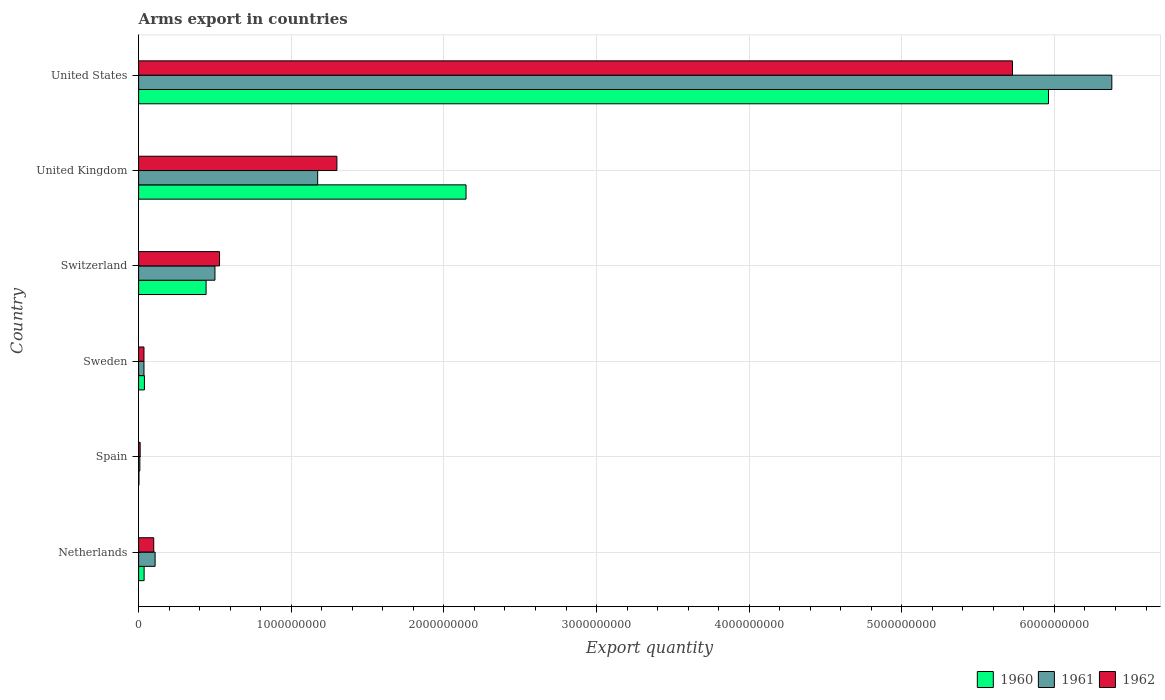How many different coloured bars are there?
Your answer should be compact. 3. Are the number of bars per tick equal to the number of legend labels?
Provide a succinct answer. Yes. Are the number of bars on each tick of the Y-axis equal?
Provide a succinct answer. Yes. What is the label of the 3rd group of bars from the top?
Provide a succinct answer. Switzerland. In how many cases, is the number of bars for a given country not equal to the number of legend labels?
Your response must be concise. 0. Across all countries, what is the maximum total arms export in 1962?
Ensure brevity in your answer.  5.72e+09. In which country was the total arms export in 1960 minimum?
Your answer should be compact. Spain. What is the total total arms export in 1961 in the graph?
Your response must be concise. 8.20e+09. What is the difference between the total arms export in 1960 in Switzerland and that in United States?
Give a very brief answer. -5.52e+09. What is the difference between the total arms export in 1960 in United Kingdom and the total arms export in 1961 in United States?
Your answer should be very brief. -4.23e+09. What is the average total arms export in 1960 per country?
Provide a short and direct response. 1.44e+09. What is the difference between the total arms export in 1960 and total arms export in 1961 in United Kingdom?
Your answer should be compact. 9.72e+08. In how many countries, is the total arms export in 1962 greater than 5400000000 ?
Give a very brief answer. 1. What is the ratio of the total arms export in 1960 in Netherlands to that in Sweden?
Ensure brevity in your answer.  0.95. Is the difference between the total arms export in 1960 in Spain and Switzerland greater than the difference between the total arms export in 1961 in Spain and Switzerland?
Make the answer very short. Yes. What is the difference between the highest and the second highest total arms export in 1962?
Give a very brief answer. 4.43e+09. What is the difference between the highest and the lowest total arms export in 1961?
Offer a very short reply. 6.37e+09. Is it the case that in every country, the sum of the total arms export in 1960 and total arms export in 1962 is greater than the total arms export in 1961?
Your response must be concise. Yes. How many bars are there?
Offer a terse response. 18. Are the values on the major ticks of X-axis written in scientific E-notation?
Make the answer very short. No. Does the graph contain grids?
Your answer should be very brief. Yes. Where does the legend appear in the graph?
Keep it short and to the point. Bottom right. How many legend labels are there?
Your answer should be very brief. 3. What is the title of the graph?
Offer a very short reply. Arms export in countries. Does "1990" appear as one of the legend labels in the graph?
Your answer should be compact. No. What is the label or title of the X-axis?
Offer a terse response. Export quantity. What is the Export quantity of 1960 in Netherlands?
Provide a short and direct response. 3.60e+07. What is the Export quantity in 1961 in Netherlands?
Your answer should be very brief. 1.08e+08. What is the Export quantity in 1962 in Netherlands?
Offer a very short reply. 9.90e+07. What is the Export quantity of 1962 in Spain?
Your answer should be very brief. 1.00e+07. What is the Export quantity of 1960 in Sweden?
Give a very brief answer. 3.80e+07. What is the Export quantity of 1961 in Sweden?
Ensure brevity in your answer.  3.50e+07. What is the Export quantity of 1962 in Sweden?
Your answer should be very brief. 3.50e+07. What is the Export quantity in 1960 in Switzerland?
Ensure brevity in your answer.  4.42e+08. What is the Export quantity in 1961 in Switzerland?
Your response must be concise. 5.00e+08. What is the Export quantity in 1962 in Switzerland?
Make the answer very short. 5.30e+08. What is the Export quantity in 1960 in United Kingdom?
Provide a succinct answer. 2.14e+09. What is the Export quantity of 1961 in United Kingdom?
Provide a succinct answer. 1.17e+09. What is the Export quantity of 1962 in United Kingdom?
Keep it short and to the point. 1.30e+09. What is the Export quantity of 1960 in United States?
Provide a succinct answer. 5.96e+09. What is the Export quantity of 1961 in United States?
Provide a succinct answer. 6.38e+09. What is the Export quantity of 1962 in United States?
Your answer should be very brief. 5.72e+09. Across all countries, what is the maximum Export quantity of 1960?
Give a very brief answer. 5.96e+09. Across all countries, what is the maximum Export quantity of 1961?
Your answer should be compact. 6.38e+09. Across all countries, what is the maximum Export quantity in 1962?
Keep it short and to the point. 5.72e+09. Across all countries, what is the minimum Export quantity of 1962?
Ensure brevity in your answer.  1.00e+07. What is the total Export quantity of 1960 in the graph?
Your response must be concise. 8.62e+09. What is the total Export quantity in 1961 in the graph?
Ensure brevity in your answer.  8.20e+09. What is the total Export quantity of 1962 in the graph?
Offer a very short reply. 7.70e+09. What is the difference between the Export quantity in 1960 in Netherlands and that in Spain?
Provide a short and direct response. 3.40e+07. What is the difference between the Export quantity of 1961 in Netherlands and that in Spain?
Offer a very short reply. 1.00e+08. What is the difference between the Export quantity of 1962 in Netherlands and that in Spain?
Keep it short and to the point. 8.90e+07. What is the difference between the Export quantity of 1960 in Netherlands and that in Sweden?
Give a very brief answer. -2.00e+06. What is the difference between the Export quantity in 1961 in Netherlands and that in Sweden?
Your answer should be compact. 7.30e+07. What is the difference between the Export quantity of 1962 in Netherlands and that in Sweden?
Provide a short and direct response. 6.40e+07. What is the difference between the Export quantity in 1960 in Netherlands and that in Switzerland?
Offer a very short reply. -4.06e+08. What is the difference between the Export quantity in 1961 in Netherlands and that in Switzerland?
Keep it short and to the point. -3.92e+08. What is the difference between the Export quantity of 1962 in Netherlands and that in Switzerland?
Give a very brief answer. -4.31e+08. What is the difference between the Export quantity of 1960 in Netherlands and that in United Kingdom?
Offer a terse response. -2.11e+09. What is the difference between the Export quantity of 1961 in Netherlands and that in United Kingdom?
Your answer should be very brief. -1.06e+09. What is the difference between the Export quantity in 1962 in Netherlands and that in United Kingdom?
Provide a succinct answer. -1.20e+09. What is the difference between the Export quantity of 1960 in Netherlands and that in United States?
Your answer should be compact. -5.92e+09. What is the difference between the Export quantity in 1961 in Netherlands and that in United States?
Offer a very short reply. -6.27e+09. What is the difference between the Export quantity in 1962 in Netherlands and that in United States?
Keep it short and to the point. -5.63e+09. What is the difference between the Export quantity in 1960 in Spain and that in Sweden?
Keep it short and to the point. -3.60e+07. What is the difference between the Export quantity in 1961 in Spain and that in Sweden?
Your response must be concise. -2.70e+07. What is the difference between the Export quantity of 1962 in Spain and that in Sweden?
Ensure brevity in your answer.  -2.50e+07. What is the difference between the Export quantity of 1960 in Spain and that in Switzerland?
Give a very brief answer. -4.40e+08. What is the difference between the Export quantity in 1961 in Spain and that in Switzerland?
Provide a succinct answer. -4.92e+08. What is the difference between the Export quantity of 1962 in Spain and that in Switzerland?
Your answer should be very brief. -5.20e+08. What is the difference between the Export quantity in 1960 in Spain and that in United Kingdom?
Make the answer very short. -2.14e+09. What is the difference between the Export quantity in 1961 in Spain and that in United Kingdom?
Offer a very short reply. -1.16e+09. What is the difference between the Export quantity in 1962 in Spain and that in United Kingdom?
Your response must be concise. -1.29e+09. What is the difference between the Export quantity in 1960 in Spain and that in United States?
Your answer should be very brief. -5.96e+09. What is the difference between the Export quantity of 1961 in Spain and that in United States?
Your response must be concise. -6.37e+09. What is the difference between the Export quantity in 1962 in Spain and that in United States?
Keep it short and to the point. -5.72e+09. What is the difference between the Export quantity in 1960 in Sweden and that in Switzerland?
Provide a succinct answer. -4.04e+08. What is the difference between the Export quantity of 1961 in Sweden and that in Switzerland?
Keep it short and to the point. -4.65e+08. What is the difference between the Export quantity of 1962 in Sweden and that in Switzerland?
Give a very brief answer. -4.95e+08. What is the difference between the Export quantity of 1960 in Sweden and that in United Kingdom?
Keep it short and to the point. -2.11e+09. What is the difference between the Export quantity of 1961 in Sweden and that in United Kingdom?
Give a very brief answer. -1.14e+09. What is the difference between the Export quantity in 1962 in Sweden and that in United Kingdom?
Provide a succinct answer. -1.26e+09. What is the difference between the Export quantity in 1960 in Sweden and that in United States?
Offer a very short reply. -5.92e+09. What is the difference between the Export quantity of 1961 in Sweden and that in United States?
Keep it short and to the point. -6.34e+09. What is the difference between the Export quantity in 1962 in Sweden and that in United States?
Provide a short and direct response. -5.69e+09. What is the difference between the Export quantity in 1960 in Switzerland and that in United Kingdom?
Provide a short and direct response. -1.70e+09. What is the difference between the Export quantity in 1961 in Switzerland and that in United Kingdom?
Offer a terse response. -6.73e+08. What is the difference between the Export quantity in 1962 in Switzerland and that in United Kingdom?
Ensure brevity in your answer.  -7.69e+08. What is the difference between the Export quantity in 1960 in Switzerland and that in United States?
Keep it short and to the point. -5.52e+09. What is the difference between the Export quantity of 1961 in Switzerland and that in United States?
Provide a short and direct response. -5.88e+09. What is the difference between the Export quantity in 1962 in Switzerland and that in United States?
Ensure brevity in your answer.  -5.20e+09. What is the difference between the Export quantity in 1960 in United Kingdom and that in United States?
Make the answer very short. -3.82e+09. What is the difference between the Export quantity of 1961 in United Kingdom and that in United States?
Give a very brief answer. -5.20e+09. What is the difference between the Export quantity of 1962 in United Kingdom and that in United States?
Offer a terse response. -4.43e+09. What is the difference between the Export quantity of 1960 in Netherlands and the Export quantity of 1961 in Spain?
Offer a very short reply. 2.80e+07. What is the difference between the Export quantity in 1960 in Netherlands and the Export quantity in 1962 in Spain?
Your response must be concise. 2.60e+07. What is the difference between the Export quantity of 1961 in Netherlands and the Export quantity of 1962 in Spain?
Provide a succinct answer. 9.80e+07. What is the difference between the Export quantity in 1960 in Netherlands and the Export quantity in 1961 in Sweden?
Your answer should be compact. 1.00e+06. What is the difference between the Export quantity in 1960 in Netherlands and the Export quantity in 1962 in Sweden?
Provide a short and direct response. 1.00e+06. What is the difference between the Export quantity in 1961 in Netherlands and the Export quantity in 1962 in Sweden?
Your answer should be very brief. 7.30e+07. What is the difference between the Export quantity of 1960 in Netherlands and the Export quantity of 1961 in Switzerland?
Give a very brief answer. -4.64e+08. What is the difference between the Export quantity in 1960 in Netherlands and the Export quantity in 1962 in Switzerland?
Ensure brevity in your answer.  -4.94e+08. What is the difference between the Export quantity of 1961 in Netherlands and the Export quantity of 1962 in Switzerland?
Give a very brief answer. -4.22e+08. What is the difference between the Export quantity of 1960 in Netherlands and the Export quantity of 1961 in United Kingdom?
Offer a very short reply. -1.14e+09. What is the difference between the Export quantity in 1960 in Netherlands and the Export quantity in 1962 in United Kingdom?
Provide a succinct answer. -1.26e+09. What is the difference between the Export quantity in 1961 in Netherlands and the Export quantity in 1962 in United Kingdom?
Your response must be concise. -1.19e+09. What is the difference between the Export quantity of 1960 in Netherlands and the Export quantity of 1961 in United States?
Offer a very short reply. -6.34e+09. What is the difference between the Export quantity in 1960 in Netherlands and the Export quantity in 1962 in United States?
Provide a succinct answer. -5.69e+09. What is the difference between the Export quantity in 1961 in Netherlands and the Export quantity in 1962 in United States?
Provide a short and direct response. -5.62e+09. What is the difference between the Export quantity in 1960 in Spain and the Export quantity in 1961 in Sweden?
Offer a terse response. -3.30e+07. What is the difference between the Export quantity in 1960 in Spain and the Export quantity in 1962 in Sweden?
Offer a terse response. -3.30e+07. What is the difference between the Export quantity of 1961 in Spain and the Export quantity of 1962 in Sweden?
Provide a succinct answer. -2.70e+07. What is the difference between the Export quantity in 1960 in Spain and the Export quantity in 1961 in Switzerland?
Your answer should be compact. -4.98e+08. What is the difference between the Export quantity in 1960 in Spain and the Export quantity in 1962 in Switzerland?
Offer a very short reply. -5.28e+08. What is the difference between the Export quantity in 1961 in Spain and the Export quantity in 1962 in Switzerland?
Provide a succinct answer. -5.22e+08. What is the difference between the Export quantity of 1960 in Spain and the Export quantity of 1961 in United Kingdom?
Offer a terse response. -1.17e+09. What is the difference between the Export quantity of 1960 in Spain and the Export quantity of 1962 in United Kingdom?
Offer a terse response. -1.30e+09. What is the difference between the Export quantity of 1961 in Spain and the Export quantity of 1962 in United Kingdom?
Give a very brief answer. -1.29e+09. What is the difference between the Export quantity of 1960 in Spain and the Export quantity of 1961 in United States?
Your response must be concise. -6.37e+09. What is the difference between the Export quantity in 1960 in Spain and the Export quantity in 1962 in United States?
Your answer should be compact. -5.72e+09. What is the difference between the Export quantity in 1961 in Spain and the Export quantity in 1962 in United States?
Offer a terse response. -5.72e+09. What is the difference between the Export quantity of 1960 in Sweden and the Export quantity of 1961 in Switzerland?
Offer a very short reply. -4.62e+08. What is the difference between the Export quantity of 1960 in Sweden and the Export quantity of 1962 in Switzerland?
Your answer should be very brief. -4.92e+08. What is the difference between the Export quantity of 1961 in Sweden and the Export quantity of 1962 in Switzerland?
Make the answer very short. -4.95e+08. What is the difference between the Export quantity in 1960 in Sweden and the Export quantity in 1961 in United Kingdom?
Make the answer very short. -1.14e+09. What is the difference between the Export quantity in 1960 in Sweden and the Export quantity in 1962 in United Kingdom?
Provide a succinct answer. -1.26e+09. What is the difference between the Export quantity of 1961 in Sweden and the Export quantity of 1962 in United Kingdom?
Make the answer very short. -1.26e+09. What is the difference between the Export quantity in 1960 in Sweden and the Export quantity in 1961 in United States?
Your answer should be compact. -6.34e+09. What is the difference between the Export quantity in 1960 in Sweden and the Export quantity in 1962 in United States?
Give a very brief answer. -5.69e+09. What is the difference between the Export quantity of 1961 in Sweden and the Export quantity of 1962 in United States?
Keep it short and to the point. -5.69e+09. What is the difference between the Export quantity of 1960 in Switzerland and the Export quantity of 1961 in United Kingdom?
Your answer should be compact. -7.31e+08. What is the difference between the Export quantity of 1960 in Switzerland and the Export quantity of 1962 in United Kingdom?
Your answer should be very brief. -8.57e+08. What is the difference between the Export quantity of 1961 in Switzerland and the Export quantity of 1962 in United Kingdom?
Ensure brevity in your answer.  -7.99e+08. What is the difference between the Export quantity in 1960 in Switzerland and the Export quantity in 1961 in United States?
Provide a short and direct response. -5.93e+09. What is the difference between the Export quantity in 1960 in Switzerland and the Export quantity in 1962 in United States?
Offer a terse response. -5.28e+09. What is the difference between the Export quantity of 1961 in Switzerland and the Export quantity of 1962 in United States?
Provide a succinct answer. -5.22e+09. What is the difference between the Export quantity in 1960 in United Kingdom and the Export quantity in 1961 in United States?
Offer a very short reply. -4.23e+09. What is the difference between the Export quantity of 1960 in United Kingdom and the Export quantity of 1962 in United States?
Provide a short and direct response. -3.58e+09. What is the difference between the Export quantity of 1961 in United Kingdom and the Export quantity of 1962 in United States?
Offer a very short reply. -4.55e+09. What is the average Export quantity in 1960 per country?
Offer a very short reply. 1.44e+09. What is the average Export quantity of 1961 per country?
Offer a terse response. 1.37e+09. What is the average Export quantity in 1962 per country?
Your response must be concise. 1.28e+09. What is the difference between the Export quantity in 1960 and Export quantity in 1961 in Netherlands?
Provide a succinct answer. -7.20e+07. What is the difference between the Export quantity of 1960 and Export quantity of 1962 in Netherlands?
Give a very brief answer. -6.30e+07. What is the difference between the Export quantity of 1961 and Export quantity of 1962 in Netherlands?
Give a very brief answer. 9.00e+06. What is the difference between the Export quantity in 1960 and Export quantity in 1961 in Spain?
Provide a succinct answer. -6.00e+06. What is the difference between the Export quantity in 1960 and Export quantity in 1962 in Spain?
Keep it short and to the point. -8.00e+06. What is the difference between the Export quantity in 1960 and Export quantity in 1961 in Switzerland?
Your answer should be very brief. -5.80e+07. What is the difference between the Export quantity of 1960 and Export quantity of 1962 in Switzerland?
Provide a succinct answer. -8.80e+07. What is the difference between the Export quantity of 1961 and Export quantity of 1962 in Switzerland?
Your response must be concise. -3.00e+07. What is the difference between the Export quantity of 1960 and Export quantity of 1961 in United Kingdom?
Your answer should be compact. 9.72e+08. What is the difference between the Export quantity of 1960 and Export quantity of 1962 in United Kingdom?
Your answer should be very brief. 8.46e+08. What is the difference between the Export quantity of 1961 and Export quantity of 1962 in United Kingdom?
Offer a terse response. -1.26e+08. What is the difference between the Export quantity in 1960 and Export quantity in 1961 in United States?
Make the answer very short. -4.15e+08. What is the difference between the Export quantity of 1960 and Export quantity of 1962 in United States?
Keep it short and to the point. 2.36e+08. What is the difference between the Export quantity in 1961 and Export quantity in 1962 in United States?
Offer a terse response. 6.51e+08. What is the ratio of the Export quantity in 1961 in Netherlands to that in Spain?
Your answer should be compact. 13.5. What is the ratio of the Export quantity in 1962 in Netherlands to that in Spain?
Provide a short and direct response. 9.9. What is the ratio of the Export quantity in 1961 in Netherlands to that in Sweden?
Your response must be concise. 3.09. What is the ratio of the Export quantity in 1962 in Netherlands to that in Sweden?
Your response must be concise. 2.83. What is the ratio of the Export quantity of 1960 in Netherlands to that in Switzerland?
Your response must be concise. 0.08. What is the ratio of the Export quantity in 1961 in Netherlands to that in Switzerland?
Offer a terse response. 0.22. What is the ratio of the Export quantity of 1962 in Netherlands to that in Switzerland?
Your answer should be very brief. 0.19. What is the ratio of the Export quantity of 1960 in Netherlands to that in United Kingdom?
Your response must be concise. 0.02. What is the ratio of the Export quantity of 1961 in Netherlands to that in United Kingdom?
Offer a very short reply. 0.09. What is the ratio of the Export quantity of 1962 in Netherlands to that in United Kingdom?
Provide a succinct answer. 0.08. What is the ratio of the Export quantity of 1960 in Netherlands to that in United States?
Keep it short and to the point. 0.01. What is the ratio of the Export quantity of 1961 in Netherlands to that in United States?
Your answer should be very brief. 0.02. What is the ratio of the Export quantity of 1962 in Netherlands to that in United States?
Keep it short and to the point. 0.02. What is the ratio of the Export quantity in 1960 in Spain to that in Sweden?
Your response must be concise. 0.05. What is the ratio of the Export quantity of 1961 in Spain to that in Sweden?
Keep it short and to the point. 0.23. What is the ratio of the Export quantity of 1962 in Spain to that in Sweden?
Provide a succinct answer. 0.29. What is the ratio of the Export quantity of 1960 in Spain to that in Switzerland?
Your response must be concise. 0. What is the ratio of the Export quantity of 1961 in Spain to that in Switzerland?
Offer a terse response. 0.02. What is the ratio of the Export quantity of 1962 in Spain to that in Switzerland?
Your answer should be very brief. 0.02. What is the ratio of the Export quantity of 1960 in Spain to that in United Kingdom?
Make the answer very short. 0. What is the ratio of the Export quantity in 1961 in Spain to that in United Kingdom?
Your answer should be very brief. 0.01. What is the ratio of the Export quantity in 1962 in Spain to that in United Kingdom?
Provide a succinct answer. 0.01. What is the ratio of the Export quantity in 1961 in Spain to that in United States?
Make the answer very short. 0. What is the ratio of the Export quantity of 1962 in Spain to that in United States?
Provide a succinct answer. 0. What is the ratio of the Export quantity of 1960 in Sweden to that in Switzerland?
Make the answer very short. 0.09. What is the ratio of the Export quantity in 1961 in Sweden to that in Switzerland?
Offer a very short reply. 0.07. What is the ratio of the Export quantity of 1962 in Sweden to that in Switzerland?
Make the answer very short. 0.07. What is the ratio of the Export quantity in 1960 in Sweden to that in United Kingdom?
Provide a short and direct response. 0.02. What is the ratio of the Export quantity in 1961 in Sweden to that in United Kingdom?
Your answer should be very brief. 0.03. What is the ratio of the Export quantity in 1962 in Sweden to that in United Kingdom?
Your answer should be very brief. 0.03. What is the ratio of the Export quantity of 1960 in Sweden to that in United States?
Offer a very short reply. 0.01. What is the ratio of the Export quantity of 1961 in Sweden to that in United States?
Ensure brevity in your answer.  0.01. What is the ratio of the Export quantity in 1962 in Sweden to that in United States?
Give a very brief answer. 0.01. What is the ratio of the Export quantity in 1960 in Switzerland to that in United Kingdom?
Your response must be concise. 0.21. What is the ratio of the Export quantity of 1961 in Switzerland to that in United Kingdom?
Offer a very short reply. 0.43. What is the ratio of the Export quantity of 1962 in Switzerland to that in United Kingdom?
Give a very brief answer. 0.41. What is the ratio of the Export quantity in 1960 in Switzerland to that in United States?
Provide a succinct answer. 0.07. What is the ratio of the Export quantity in 1961 in Switzerland to that in United States?
Keep it short and to the point. 0.08. What is the ratio of the Export quantity in 1962 in Switzerland to that in United States?
Your answer should be compact. 0.09. What is the ratio of the Export quantity in 1960 in United Kingdom to that in United States?
Provide a succinct answer. 0.36. What is the ratio of the Export quantity in 1961 in United Kingdom to that in United States?
Offer a very short reply. 0.18. What is the ratio of the Export quantity of 1962 in United Kingdom to that in United States?
Make the answer very short. 0.23. What is the difference between the highest and the second highest Export quantity in 1960?
Ensure brevity in your answer.  3.82e+09. What is the difference between the highest and the second highest Export quantity of 1961?
Provide a short and direct response. 5.20e+09. What is the difference between the highest and the second highest Export quantity of 1962?
Ensure brevity in your answer.  4.43e+09. What is the difference between the highest and the lowest Export quantity of 1960?
Offer a terse response. 5.96e+09. What is the difference between the highest and the lowest Export quantity in 1961?
Keep it short and to the point. 6.37e+09. What is the difference between the highest and the lowest Export quantity in 1962?
Keep it short and to the point. 5.72e+09. 